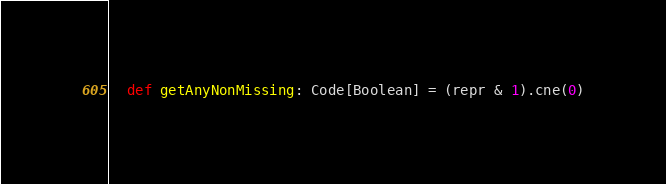<code> <loc_0><loc_0><loc_500><loc_500><_Scala_>  def getAnyNonMissing: Code[Boolean] = (repr & 1).cne(0)
</code> 